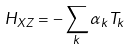<formula> <loc_0><loc_0><loc_500><loc_500>H _ { X Z } = - \sum _ { k } \alpha _ { k } T _ { k }</formula> 